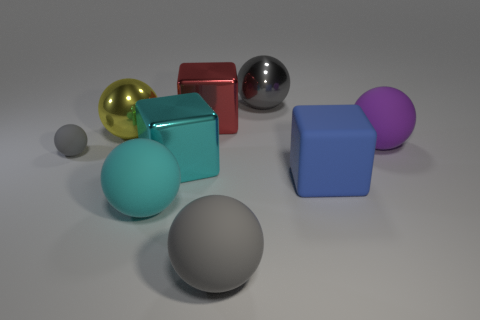Are there any metallic balls of the same color as the small rubber thing?
Your answer should be very brief. Yes. What is the large gray ball behind the tiny gray sphere made of?
Give a very brief answer. Metal. There is a gray rubber object that is behind the large blue matte thing; what number of rubber spheres are in front of it?
Give a very brief answer. 2. What number of gray matte objects are the same shape as the big cyan matte thing?
Provide a succinct answer. 2. How many cyan rubber balls are there?
Provide a short and direct response. 1. What is the color of the large ball behind the big red thing?
Offer a terse response. Gray. There is a metal thing on the right side of the big gray sphere to the left of the big gray metallic thing; what color is it?
Ensure brevity in your answer.  Gray. There is another metal cube that is the same size as the cyan metal block; what is its color?
Offer a terse response. Red. How many balls are in front of the large yellow shiny sphere and behind the tiny gray matte sphere?
Offer a terse response. 1. What shape is the other matte object that is the same color as the tiny thing?
Keep it short and to the point. Sphere. 